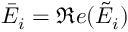Convert formula to latex. <formula><loc_0><loc_0><loc_500><loc_500>\bar { E } _ { i } = \Re e ( \tilde { E } _ { i } )</formula> 